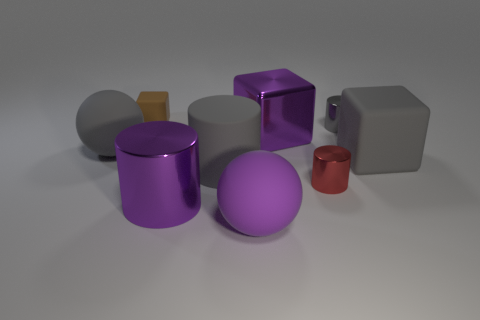Subtract all gray rubber cubes. How many cubes are left? 2 Subtract all gray cubes. How many gray cylinders are left? 2 Subtract all gray cylinders. How many cylinders are left? 2 Subtract all cylinders. How many objects are left? 5 Subtract all cyan blocks. Subtract all blue balls. How many blocks are left? 3 Add 3 purple rubber objects. How many purple rubber objects are left? 4 Add 8 brown blocks. How many brown blocks exist? 9 Subtract 1 gray balls. How many objects are left? 8 Subtract all big gray matte objects. Subtract all gray metallic cylinders. How many objects are left? 5 